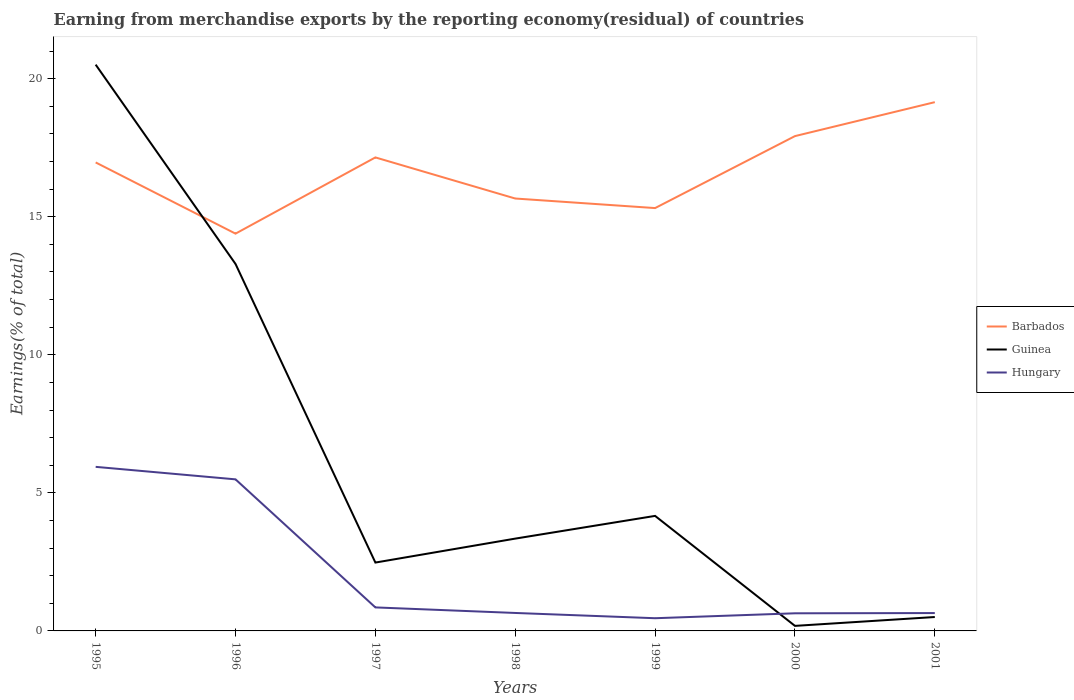How many different coloured lines are there?
Your answer should be very brief. 3. Is the number of lines equal to the number of legend labels?
Make the answer very short. Yes. Across all years, what is the maximum percentage of amount earned from merchandise exports in Hungary?
Provide a short and direct response. 0.46. What is the total percentage of amount earned from merchandise exports in Barbados in the graph?
Provide a short and direct response. -3.53. What is the difference between the highest and the second highest percentage of amount earned from merchandise exports in Hungary?
Your response must be concise. 5.48. Is the percentage of amount earned from merchandise exports in Barbados strictly greater than the percentage of amount earned from merchandise exports in Hungary over the years?
Provide a short and direct response. No. How many lines are there?
Keep it short and to the point. 3. How many years are there in the graph?
Offer a very short reply. 7. What is the difference between two consecutive major ticks on the Y-axis?
Your response must be concise. 5. Are the values on the major ticks of Y-axis written in scientific E-notation?
Ensure brevity in your answer.  No. Where does the legend appear in the graph?
Your answer should be compact. Center right. How many legend labels are there?
Give a very brief answer. 3. What is the title of the graph?
Provide a short and direct response. Earning from merchandise exports by the reporting economy(residual) of countries. What is the label or title of the X-axis?
Provide a short and direct response. Years. What is the label or title of the Y-axis?
Your answer should be compact. Earnings(% of total). What is the Earnings(% of total) of Barbados in 1995?
Ensure brevity in your answer.  16.97. What is the Earnings(% of total) of Guinea in 1995?
Ensure brevity in your answer.  20.51. What is the Earnings(% of total) in Hungary in 1995?
Ensure brevity in your answer.  5.94. What is the Earnings(% of total) of Barbados in 1996?
Make the answer very short. 14.39. What is the Earnings(% of total) in Guinea in 1996?
Make the answer very short. 13.29. What is the Earnings(% of total) in Hungary in 1996?
Give a very brief answer. 5.49. What is the Earnings(% of total) of Barbados in 1997?
Ensure brevity in your answer.  17.15. What is the Earnings(% of total) of Guinea in 1997?
Offer a terse response. 2.48. What is the Earnings(% of total) in Hungary in 1997?
Offer a very short reply. 0.85. What is the Earnings(% of total) in Barbados in 1998?
Your answer should be compact. 15.66. What is the Earnings(% of total) in Guinea in 1998?
Ensure brevity in your answer.  3.34. What is the Earnings(% of total) in Hungary in 1998?
Provide a succinct answer. 0.65. What is the Earnings(% of total) in Barbados in 1999?
Provide a succinct answer. 15.31. What is the Earnings(% of total) of Guinea in 1999?
Ensure brevity in your answer.  4.17. What is the Earnings(% of total) in Hungary in 1999?
Offer a terse response. 0.46. What is the Earnings(% of total) of Barbados in 2000?
Provide a short and direct response. 17.92. What is the Earnings(% of total) of Guinea in 2000?
Provide a succinct answer. 0.18. What is the Earnings(% of total) of Hungary in 2000?
Offer a terse response. 0.64. What is the Earnings(% of total) in Barbados in 2001?
Your answer should be very brief. 19.15. What is the Earnings(% of total) of Guinea in 2001?
Make the answer very short. 0.5. What is the Earnings(% of total) in Hungary in 2001?
Offer a very short reply. 0.65. Across all years, what is the maximum Earnings(% of total) in Barbados?
Ensure brevity in your answer.  19.15. Across all years, what is the maximum Earnings(% of total) in Guinea?
Provide a short and direct response. 20.51. Across all years, what is the maximum Earnings(% of total) of Hungary?
Offer a very short reply. 5.94. Across all years, what is the minimum Earnings(% of total) of Barbados?
Provide a short and direct response. 14.39. Across all years, what is the minimum Earnings(% of total) of Guinea?
Make the answer very short. 0.18. Across all years, what is the minimum Earnings(% of total) of Hungary?
Give a very brief answer. 0.46. What is the total Earnings(% of total) in Barbados in the graph?
Provide a short and direct response. 116.55. What is the total Earnings(% of total) of Guinea in the graph?
Your answer should be compact. 44.47. What is the total Earnings(% of total) of Hungary in the graph?
Your answer should be compact. 14.68. What is the difference between the Earnings(% of total) in Barbados in 1995 and that in 1996?
Give a very brief answer. 2.58. What is the difference between the Earnings(% of total) of Guinea in 1995 and that in 1996?
Offer a terse response. 7.22. What is the difference between the Earnings(% of total) in Hungary in 1995 and that in 1996?
Give a very brief answer. 0.45. What is the difference between the Earnings(% of total) in Barbados in 1995 and that in 1997?
Offer a very short reply. -0.18. What is the difference between the Earnings(% of total) in Guinea in 1995 and that in 1997?
Your response must be concise. 18.03. What is the difference between the Earnings(% of total) in Hungary in 1995 and that in 1997?
Provide a succinct answer. 5.09. What is the difference between the Earnings(% of total) in Barbados in 1995 and that in 1998?
Offer a very short reply. 1.31. What is the difference between the Earnings(% of total) in Guinea in 1995 and that in 1998?
Make the answer very short. 17.17. What is the difference between the Earnings(% of total) of Hungary in 1995 and that in 1998?
Your response must be concise. 5.29. What is the difference between the Earnings(% of total) in Barbados in 1995 and that in 1999?
Your answer should be very brief. 1.65. What is the difference between the Earnings(% of total) of Guinea in 1995 and that in 1999?
Provide a succinct answer. 16.34. What is the difference between the Earnings(% of total) in Hungary in 1995 and that in 1999?
Your answer should be very brief. 5.48. What is the difference between the Earnings(% of total) in Barbados in 1995 and that in 2000?
Offer a very short reply. -0.95. What is the difference between the Earnings(% of total) in Guinea in 1995 and that in 2000?
Your answer should be compact. 20.33. What is the difference between the Earnings(% of total) in Hungary in 1995 and that in 2000?
Offer a terse response. 5.3. What is the difference between the Earnings(% of total) in Barbados in 1995 and that in 2001?
Your answer should be compact. -2.18. What is the difference between the Earnings(% of total) in Guinea in 1995 and that in 2001?
Offer a terse response. 20. What is the difference between the Earnings(% of total) in Hungary in 1995 and that in 2001?
Your response must be concise. 5.3. What is the difference between the Earnings(% of total) of Barbados in 1996 and that in 1997?
Keep it short and to the point. -2.76. What is the difference between the Earnings(% of total) of Guinea in 1996 and that in 1997?
Your response must be concise. 10.81. What is the difference between the Earnings(% of total) of Hungary in 1996 and that in 1997?
Provide a succinct answer. 4.64. What is the difference between the Earnings(% of total) of Barbados in 1996 and that in 1998?
Provide a succinct answer. -1.27. What is the difference between the Earnings(% of total) in Guinea in 1996 and that in 1998?
Ensure brevity in your answer.  9.95. What is the difference between the Earnings(% of total) in Hungary in 1996 and that in 1998?
Make the answer very short. 4.84. What is the difference between the Earnings(% of total) in Barbados in 1996 and that in 1999?
Ensure brevity in your answer.  -0.93. What is the difference between the Earnings(% of total) in Guinea in 1996 and that in 1999?
Provide a short and direct response. 9.12. What is the difference between the Earnings(% of total) of Hungary in 1996 and that in 1999?
Ensure brevity in your answer.  5.03. What is the difference between the Earnings(% of total) in Barbados in 1996 and that in 2000?
Offer a terse response. -3.53. What is the difference between the Earnings(% of total) of Guinea in 1996 and that in 2000?
Make the answer very short. 13.11. What is the difference between the Earnings(% of total) in Hungary in 1996 and that in 2000?
Ensure brevity in your answer.  4.85. What is the difference between the Earnings(% of total) of Barbados in 1996 and that in 2001?
Ensure brevity in your answer.  -4.76. What is the difference between the Earnings(% of total) of Guinea in 1996 and that in 2001?
Offer a very short reply. 12.79. What is the difference between the Earnings(% of total) of Hungary in 1996 and that in 2001?
Provide a short and direct response. 4.84. What is the difference between the Earnings(% of total) of Barbados in 1997 and that in 1998?
Ensure brevity in your answer.  1.49. What is the difference between the Earnings(% of total) in Guinea in 1997 and that in 1998?
Offer a very short reply. -0.87. What is the difference between the Earnings(% of total) of Hungary in 1997 and that in 1998?
Ensure brevity in your answer.  0.2. What is the difference between the Earnings(% of total) in Barbados in 1997 and that in 1999?
Your answer should be very brief. 1.83. What is the difference between the Earnings(% of total) in Guinea in 1997 and that in 1999?
Your answer should be very brief. -1.69. What is the difference between the Earnings(% of total) in Hungary in 1997 and that in 1999?
Keep it short and to the point. 0.39. What is the difference between the Earnings(% of total) in Barbados in 1997 and that in 2000?
Give a very brief answer. -0.77. What is the difference between the Earnings(% of total) in Guinea in 1997 and that in 2000?
Keep it short and to the point. 2.29. What is the difference between the Earnings(% of total) in Hungary in 1997 and that in 2000?
Your answer should be compact. 0.21. What is the difference between the Earnings(% of total) of Barbados in 1997 and that in 2001?
Provide a short and direct response. -2. What is the difference between the Earnings(% of total) in Guinea in 1997 and that in 2001?
Provide a short and direct response. 1.97. What is the difference between the Earnings(% of total) in Hungary in 1997 and that in 2001?
Ensure brevity in your answer.  0.2. What is the difference between the Earnings(% of total) of Barbados in 1998 and that in 1999?
Your response must be concise. 0.35. What is the difference between the Earnings(% of total) of Guinea in 1998 and that in 1999?
Your response must be concise. -0.82. What is the difference between the Earnings(% of total) in Hungary in 1998 and that in 1999?
Provide a short and direct response. 0.19. What is the difference between the Earnings(% of total) of Barbados in 1998 and that in 2000?
Your answer should be very brief. -2.26. What is the difference between the Earnings(% of total) of Guinea in 1998 and that in 2000?
Your answer should be very brief. 3.16. What is the difference between the Earnings(% of total) in Hungary in 1998 and that in 2000?
Your answer should be compact. 0.01. What is the difference between the Earnings(% of total) of Barbados in 1998 and that in 2001?
Your answer should be very brief. -3.49. What is the difference between the Earnings(% of total) in Guinea in 1998 and that in 2001?
Your response must be concise. 2.84. What is the difference between the Earnings(% of total) of Hungary in 1998 and that in 2001?
Your response must be concise. 0. What is the difference between the Earnings(% of total) of Barbados in 1999 and that in 2000?
Ensure brevity in your answer.  -2.61. What is the difference between the Earnings(% of total) of Guinea in 1999 and that in 2000?
Make the answer very short. 3.98. What is the difference between the Earnings(% of total) of Hungary in 1999 and that in 2000?
Your answer should be compact. -0.18. What is the difference between the Earnings(% of total) of Barbados in 1999 and that in 2001?
Offer a terse response. -3.84. What is the difference between the Earnings(% of total) in Guinea in 1999 and that in 2001?
Ensure brevity in your answer.  3.66. What is the difference between the Earnings(% of total) of Hungary in 1999 and that in 2001?
Offer a very short reply. -0.19. What is the difference between the Earnings(% of total) in Barbados in 2000 and that in 2001?
Make the answer very short. -1.23. What is the difference between the Earnings(% of total) of Guinea in 2000 and that in 2001?
Offer a very short reply. -0.32. What is the difference between the Earnings(% of total) of Hungary in 2000 and that in 2001?
Your answer should be compact. -0.01. What is the difference between the Earnings(% of total) of Barbados in 1995 and the Earnings(% of total) of Guinea in 1996?
Offer a very short reply. 3.68. What is the difference between the Earnings(% of total) of Barbados in 1995 and the Earnings(% of total) of Hungary in 1996?
Provide a succinct answer. 11.48. What is the difference between the Earnings(% of total) in Guinea in 1995 and the Earnings(% of total) in Hungary in 1996?
Ensure brevity in your answer.  15.02. What is the difference between the Earnings(% of total) in Barbados in 1995 and the Earnings(% of total) in Guinea in 1997?
Your answer should be compact. 14.49. What is the difference between the Earnings(% of total) in Barbados in 1995 and the Earnings(% of total) in Hungary in 1997?
Provide a short and direct response. 16.11. What is the difference between the Earnings(% of total) of Guinea in 1995 and the Earnings(% of total) of Hungary in 1997?
Provide a succinct answer. 19.66. What is the difference between the Earnings(% of total) of Barbados in 1995 and the Earnings(% of total) of Guinea in 1998?
Offer a terse response. 13.62. What is the difference between the Earnings(% of total) in Barbados in 1995 and the Earnings(% of total) in Hungary in 1998?
Your answer should be very brief. 16.32. What is the difference between the Earnings(% of total) in Guinea in 1995 and the Earnings(% of total) in Hungary in 1998?
Your answer should be very brief. 19.86. What is the difference between the Earnings(% of total) in Barbados in 1995 and the Earnings(% of total) in Guinea in 1999?
Your answer should be compact. 12.8. What is the difference between the Earnings(% of total) in Barbados in 1995 and the Earnings(% of total) in Hungary in 1999?
Offer a very short reply. 16.51. What is the difference between the Earnings(% of total) of Guinea in 1995 and the Earnings(% of total) of Hungary in 1999?
Ensure brevity in your answer.  20.05. What is the difference between the Earnings(% of total) of Barbados in 1995 and the Earnings(% of total) of Guinea in 2000?
Give a very brief answer. 16.78. What is the difference between the Earnings(% of total) of Barbados in 1995 and the Earnings(% of total) of Hungary in 2000?
Your answer should be very brief. 16.33. What is the difference between the Earnings(% of total) of Guinea in 1995 and the Earnings(% of total) of Hungary in 2000?
Ensure brevity in your answer.  19.87. What is the difference between the Earnings(% of total) in Barbados in 1995 and the Earnings(% of total) in Guinea in 2001?
Your response must be concise. 16.46. What is the difference between the Earnings(% of total) of Barbados in 1995 and the Earnings(% of total) of Hungary in 2001?
Your answer should be compact. 16.32. What is the difference between the Earnings(% of total) of Guinea in 1995 and the Earnings(% of total) of Hungary in 2001?
Give a very brief answer. 19.86. What is the difference between the Earnings(% of total) in Barbados in 1996 and the Earnings(% of total) in Guinea in 1997?
Offer a very short reply. 11.91. What is the difference between the Earnings(% of total) in Barbados in 1996 and the Earnings(% of total) in Hungary in 1997?
Your answer should be very brief. 13.54. What is the difference between the Earnings(% of total) of Guinea in 1996 and the Earnings(% of total) of Hungary in 1997?
Offer a very short reply. 12.44. What is the difference between the Earnings(% of total) of Barbados in 1996 and the Earnings(% of total) of Guinea in 1998?
Ensure brevity in your answer.  11.05. What is the difference between the Earnings(% of total) of Barbados in 1996 and the Earnings(% of total) of Hungary in 1998?
Offer a very short reply. 13.74. What is the difference between the Earnings(% of total) in Guinea in 1996 and the Earnings(% of total) in Hungary in 1998?
Ensure brevity in your answer.  12.64. What is the difference between the Earnings(% of total) in Barbados in 1996 and the Earnings(% of total) in Guinea in 1999?
Provide a succinct answer. 10.22. What is the difference between the Earnings(% of total) of Barbados in 1996 and the Earnings(% of total) of Hungary in 1999?
Your answer should be compact. 13.93. What is the difference between the Earnings(% of total) in Guinea in 1996 and the Earnings(% of total) in Hungary in 1999?
Offer a terse response. 12.83. What is the difference between the Earnings(% of total) of Barbados in 1996 and the Earnings(% of total) of Guinea in 2000?
Give a very brief answer. 14.21. What is the difference between the Earnings(% of total) of Barbados in 1996 and the Earnings(% of total) of Hungary in 2000?
Offer a terse response. 13.75. What is the difference between the Earnings(% of total) in Guinea in 1996 and the Earnings(% of total) in Hungary in 2000?
Your answer should be very brief. 12.65. What is the difference between the Earnings(% of total) in Barbados in 1996 and the Earnings(% of total) in Guinea in 2001?
Keep it short and to the point. 13.88. What is the difference between the Earnings(% of total) of Barbados in 1996 and the Earnings(% of total) of Hungary in 2001?
Offer a very short reply. 13.74. What is the difference between the Earnings(% of total) in Guinea in 1996 and the Earnings(% of total) in Hungary in 2001?
Provide a short and direct response. 12.64. What is the difference between the Earnings(% of total) in Barbados in 1997 and the Earnings(% of total) in Guinea in 1998?
Provide a succinct answer. 13.81. What is the difference between the Earnings(% of total) in Barbados in 1997 and the Earnings(% of total) in Hungary in 1998?
Offer a terse response. 16.5. What is the difference between the Earnings(% of total) in Guinea in 1997 and the Earnings(% of total) in Hungary in 1998?
Ensure brevity in your answer.  1.83. What is the difference between the Earnings(% of total) in Barbados in 1997 and the Earnings(% of total) in Guinea in 1999?
Give a very brief answer. 12.98. What is the difference between the Earnings(% of total) of Barbados in 1997 and the Earnings(% of total) of Hungary in 1999?
Your answer should be compact. 16.69. What is the difference between the Earnings(% of total) of Guinea in 1997 and the Earnings(% of total) of Hungary in 1999?
Offer a very short reply. 2.02. What is the difference between the Earnings(% of total) in Barbados in 1997 and the Earnings(% of total) in Guinea in 2000?
Ensure brevity in your answer.  16.97. What is the difference between the Earnings(% of total) in Barbados in 1997 and the Earnings(% of total) in Hungary in 2000?
Provide a short and direct response. 16.51. What is the difference between the Earnings(% of total) of Guinea in 1997 and the Earnings(% of total) of Hungary in 2000?
Offer a terse response. 1.84. What is the difference between the Earnings(% of total) in Barbados in 1997 and the Earnings(% of total) in Guinea in 2001?
Offer a very short reply. 16.64. What is the difference between the Earnings(% of total) in Barbados in 1997 and the Earnings(% of total) in Hungary in 2001?
Offer a very short reply. 16.5. What is the difference between the Earnings(% of total) of Guinea in 1997 and the Earnings(% of total) of Hungary in 2001?
Your answer should be compact. 1.83. What is the difference between the Earnings(% of total) of Barbados in 1998 and the Earnings(% of total) of Guinea in 1999?
Ensure brevity in your answer.  11.49. What is the difference between the Earnings(% of total) in Barbados in 1998 and the Earnings(% of total) in Hungary in 1999?
Your answer should be compact. 15.2. What is the difference between the Earnings(% of total) of Guinea in 1998 and the Earnings(% of total) of Hungary in 1999?
Your answer should be very brief. 2.88. What is the difference between the Earnings(% of total) of Barbados in 1998 and the Earnings(% of total) of Guinea in 2000?
Keep it short and to the point. 15.48. What is the difference between the Earnings(% of total) of Barbados in 1998 and the Earnings(% of total) of Hungary in 2000?
Ensure brevity in your answer.  15.02. What is the difference between the Earnings(% of total) in Guinea in 1998 and the Earnings(% of total) in Hungary in 2000?
Your response must be concise. 2.7. What is the difference between the Earnings(% of total) of Barbados in 1998 and the Earnings(% of total) of Guinea in 2001?
Your response must be concise. 15.16. What is the difference between the Earnings(% of total) of Barbados in 1998 and the Earnings(% of total) of Hungary in 2001?
Your answer should be compact. 15.01. What is the difference between the Earnings(% of total) of Guinea in 1998 and the Earnings(% of total) of Hungary in 2001?
Provide a short and direct response. 2.7. What is the difference between the Earnings(% of total) of Barbados in 1999 and the Earnings(% of total) of Guinea in 2000?
Ensure brevity in your answer.  15.13. What is the difference between the Earnings(% of total) in Barbados in 1999 and the Earnings(% of total) in Hungary in 2000?
Your answer should be very brief. 14.68. What is the difference between the Earnings(% of total) in Guinea in 1999 and the Earnings(% of total) in Hungary in 2000?
Offer a terse response. 3.53. What is the difference between the Earnings(% of total) of Barbados in 1999 and the Earnings(% of total) of Guinea in 2001?
Provide a succinct answer. 14.81. What is the difference between the Earnings(% of total) of Barbados in 1999 and the Earnings(% of total) of Hungary in 2001?
Make the answer very short. 14.67. What is the difference between the Earnings(% of total) in Guinea in 1999 and the Earnings(% of total) in Hungary in 2001?
Your response must be concise. 3.52. What is the difference between the Earnings(% of total) of Barbados in 2000 and the Earnings(% of total) of Guinea in 2001?
Ensure brevity in your answer.  17.42. What is the difference between the Earnings(% of total) in Barbados in 2000 and the Earnings(% of total) in Hungary in 2001?
Give a very brief answer. 17.27. What is the difference between the Earnings(% of total) of Guinea in 2000 and the Earnings(% of total) of Hungary in 2001?
Provide a short and direct response. -0.46. What is the average Earnings(% of total) of Barbados per year?
Your response must be concise. 16.65. What is the average Earnings(% of total) of Guinea per year?
Offer a terse response. 6.35. What is the average Earnings(% of total) of Hungary per year?
Provide a succinct answer. 2.1. In the year 1995, what is the difference between the Earnings(% of total) of Barbados and Earnings(% of total) of Guinea?
Your answer should be very brief. -3.54. In the year 1995, what is the difference between the Earnings(% of total) of Barbados and Earnings(% of total) of Hungary?
Provide a short and direct response. 11.02. In the year 1995, what is the difference between the Earnings(% of total) in Guinea and Earnings(% of total) in Hungary?
Offer a terse response. 14.57. In the year 1996, what is the difference between the Earnings(% of total) in Barbados and Earnings(% of total) in Guinea?
Give a very brief answer. 1.1. In the year 1996, what is the difference between the Earnings(% of total) of Barbados and Earnings(% of total) of Hungary?
Provide a succinct answer. 8.9. In the year 1996, what is the difference between the Earnings(% of total) in Guinea and Earnings(% of total) in Hungary?
Your answer should be very brief. 7.8. In the year 1997, what is the difference between the Earnings(% of total) of Barbados and Earnings(% of total) of Guinea?
Make the answer very short. 14.67. In the year 1997, what is the difference between the Earnings(% of total) of Barbados and Earnings(% of total) of Hungary?
Offer a very short reply. 16.3. In the year 1997, what is the difference between the Earnings(% of total) in Guinea and Earnings(% of total) in Hungary?
Your answer should be very brief. 1.62. In the year 1998, what is the difference between the Earnings(% of total) of Barbados and Earnings(% of total) of Guinea?
Keep it short and to the point. 12.32. In the year 1998, what is the difference between the Earnings(% of total) of Barbados and Earnings(% of total) of Hungary?
Keep it short and to the point. 15.01. In the year 1998, what is the difference between the Earnings(% of total) in Guinea and Earnings(% of total) in Hungary?
Provide a succinct answer. 2.69. In the year 1999, what is the difference between the Earnings(% of total) of Barbados and Earnings(% of total) of Guinea?
Make the answer very short. 11.15. In the year 1999, what is the difference between the Earnings(% of total) in Barbados and Earnings(% of total) in Hungary?
Your answer should be very brief. 14.85. In the year 1999, what is the difference between the Earnings(% of total) of Guinea and Earnings(% of total) of Hungary?
Keep it short and to the point. 3.71. In the year 2000, what is the difference between the Earnings(% of total) of Barbados and Earnings(% of total) of Guinea?
Your response must be concise. 17.74. In the year 2000, what is the difference between the Earnings(% of total) of Barbados and Earnings(% of total) of Hungary?
Your answer should be compact. 17.28. In the year 2000, what is the difference between the Earnings(% of total) in Guinea and Earnings(% of total) in Hungary?
Keep it short and to the point. -0.46. In the year 2001, what is the difference between the Earnings(% of total) in Barbados and Earnings(% of total) in Guinea?
Ensure brevity in your answer.  18.65. In the year 2001, what is the difference between the Earnings(% of total) of Barbados and Earnings(% of total) of Hungary?
Provide a short and direct response. 18.5. In the year 2001, what is the difference between the Earnings(% of total) of Guinea and Earnings(% of total) of Hungary?
Provide a succinct answer. -0.14. What is the ratio of the Earnings(% of total) in Barbados in 1995 to that in 1996?
Offer a terse response. 1.18. What is the ratio of the Earnings(% of total) of Guinea in 1995 to that in 1996?
Ensure brevity in your answer.  1.54. What is the ratio of the Earnings(% of total) of Hungary in 1995 to that in 1996?
Give a very brief answer. 1.08. What is the ratio of the Earnings(% of total) of Guinea in 1995 to that in 1997?
Make the answer very short. 8.28. What is the ratio of the Earnings(% of total) of Hungary in 1995 to that in 1997?
Your answer should be compact. 6.98. What is the ratio of the Earnings(% of total) of Barbados in 1995 to that in 1998?
Offer a terse response. 1.08. What is the ratio of the Earnings(% of total) in Guinea in 1995 to that in 1998?
Make the answer very short. 6.13. What is the ratio of the Earnings(% of total) of Hungary in 1995 to that in 1998?
Your answer should be compact. 9.13. What is the ratio of the Earnings(% of total) in Barbados in 1995 to that in 1999?
Make the answer very short. 1.11. What is the ratio of the Earnings(% of total) of Guinea in 1995 to that in 1999?
Provide a short and direct response. 4.92. What is the ratio of the Earnings(% of total) in Hungary in 1995 to that in 1999?
Offer a terse response. 12.92. What is the ratio of the Earnings(% of total) in Barbados in 1995 to that in 2000?
Give a very brief answer. 0.95. What is the ratio of the Earnings(% of total) in Guinea in 1995 to that in 2000?
Provide a short and direct response. 112.28. What is the ratio of the Earnings(% of total) in Hungary in 1995 to that in 2000?
Provide a short and direct response. 9.31. What is the ratio of the Earnings(% of total) of Barbados in 1995 to that in 2001?
Give a very brief answer. 0.89. What is the ratio of the Earnings(% of total) in Guinea in 1995 to that in 2001?
Make the answer very short. 40.72. What is the ratio of the Earnings(% of total) in Hungary in 1995 to that in 2001?
Ensure brevity in your answer.  9.19. What is the ratio of the Earnings(% of total) in Barbados in 1996 to that in 1997?
Your response must be concise. 0.84. What is the ratio of the Earnings(% of total) in Guinea in 1996 to that in 1997?
Offer a terse response. 5.37. What is the ratio of the Earnings(% of total) of Hungary in 1996 to that in 1997?
Keep it short and to the point. 6.45. What is the ratio of the Earnings(% of total) of Barbados in 1996 to that in 1998?
Ensure brevity in your answer.  0.92. What is the ratio of the Earnings(% of total) in Guinea in 1996 to that in 1998?
Ensure brevity in your answer.  3.98. What is the ratio of the Earnings(% of total) of Hungary in 1996 to that in 1998?
Your answer should be very brief. 8.44. What is the ratio of the Earnings(% of total) in Barbados in 1996 to that in 1999?
Your response must be concise. 0.94. What is the ratio of the Earnings(% of total) in Guinea in 1996 to that in 1999?
Provide a succinct answer. 3.19. What is the ratio of the Earnings(% of total) in Hungary in 1996 to that in 1999?
Your answer should be very brief. 11.94. What is the ratio of the Earnings(% of total) of Barbados in 1996 to that in 2000?
Make the answer very short. 0.8. What is the ratio of the Earnings(% of total) of Guinea in 1996 to that in 2000?
Provide a succinct answer. 72.76. What is the ratio of the Earnings(% of total) of Hungary in 1996 to that in 2000?
Keep it short and to the point. 8.6. What is the ratio of the Earnings(% of total) in Barbados in 1996 to that in 2001?
Your response must be concise. 0.75. What is the ratio of the Earnings(% of total) in Guinea in 1996 to that in 2001?
Your answer should be very brief. 26.39. What is the ratio of the Earnings(% of total) of Hungary in 1996 to that in 2001?
Offer a terse response. 8.49. What is the ratio of the Earnings(% of total) in Barbados in 1997 to that in 1998?
Ensure brevity in your answer.  1.09. What is the ratio of the Earnings(% of total) in Guinea in 1997 to that in 1998?
Your response must be concise. 0.74. What is the ratio of the Earnings(% of total) in Hungary in 1997 to that in 1998?
Offer a terse response. 1.31. What is the ratio of the Earnings(% of total) of Barbados in 1997 to that in 1999?
Keep it short and to the point. 1.12. What is the ratio of the Earnings(% of total) of Guinea in 1997 to that in 1999?
Give a very brief answer. 0.59. What is the ratio of the Earnings(% of total) in Hungary in 1997 to that in 1999?
Provide a succinct answer. 1.85. What is the ratio of the Earnings(% of total) of Barbados in 1997 to that in 2000?
Your response must be concise. 0.96. What is the ratio of the Earnings(% of total) in Guinea in 1997 to that in 2000?
Give a very brief answer. 13.55. What is the ratio of the Earnings(% of total) in Hungary in 1997 to that in 2000?
Ensure brevity in your answer.  1.33. What is the ratio of the Earnings(% of total) in Barbados in 1997 to that in 2001?
Ensure brevity in your answer.  0.9. What is the ratio of the Earnings(% of total) in Guinea in 1997 to that in 2001?
Give a very brief answer. 4.92. What is the ratio of the Earnings(% of total) of Hungary in 1997 to that in 2001?
Offer a terse response. 1.32. What is the ratio of the Earnings(% of total) of Barbados in 1998 to that in 1999?
Ensure brevity in your answer.  1.02. What is the ratio of the Earnings(% of total) of Guinea in 1998 to that in 1999?
Your response must be concise. 0.8. What is the ratio of the Earnings(% of total) of Hungary in 1998 to that in 1999?
Give a very brief answer. 1.41. What is the ratio of the Earnings(% of total) of Barbados in 1998 to that in 2000?
Make the answer very short. 0.87. What is the ratio of the Earnings(% of total) in Guinea in 1998 to that in 2000?
Offer a terse response. 18.3. What is the ratio of the Earnings(% of total) of Hungary in 1998 to that in 2000?
Provide a succinct answer. 1.02. What is the ratio of the Earnings(% of total) in Barbados in 1998 to that in 2001?
Your response must be concise. 0.82. What is the ratio of the Earnings(% of total) in Guinea in 1998 to that in 2001?
Keep it short and to the point. 6.64. What is the ratio of the Earnings(% of total) in Hungary in 1998 to that in 2001?
Your answer should be very brief. 1.01. What is the ratio of the Earnings(% of total) in Barbados in 1999 to that in 2000?
Your answer should be compact. 0.85. What is the ratio of the Earnings(% of total) of Guinea in 1999 to that in 2000?
Ensure brevity in your answer.  22.81. What is the ratio of the Earnings(% of total) in Hungary in 1999 to that in 2000?
Offer a terse response. 0.72. What is the ratio of the Earnings(% of total) of Barbados in 1999 to that in 2001?
Keep it short and to the point. 0.8. What is the ratio of the Earnings(% of total) of Guinea in 1999 to that in 2001?
Ensure brevity in your answer.  8.27. What is the ratio of the Earnings(% of total) of Hungary in 1999 to that in 2001?
Make the answer very short. 0.71. What is the ratio of the Earnings(% of total) in Barbados in 2000 to that in 2001?
Ensure brevity in your answer.  0.94. What is the ratio of the Earnings(% of total) of Guinea in 2000 to that in 2001?
Offer a very short reply. 0.36. What is the ratio of the Earnings(% of total) of Hungary in 2000 to that in 2001?
Your answer should be very brief. 0.99. What is the difference between the highest and the second highest Earnings(% of total) in Barbados?
Your response must be concise. 1.23. What is the difference between the highest and the second highest Earnings(% of total) in Guinea?
Provide a short and direct response. 7.22. What is the difference between the highest and the second highest Earnings(% of total) in Hungary?
Ensure brevity in your answer.  0.45. What is the difference between the highest and the lowest Earnings(% of total) in Barbados?
Ensure brevity in your answer.  4.76. What is the difference between the highest and the lowest Earnings(% of total) in Guinea?
Your answer should be compact. 20.33. What is the difference between the highest and the lowest Earnings(% of total) of Hungary?
Offer a very short reply. 5.48. 